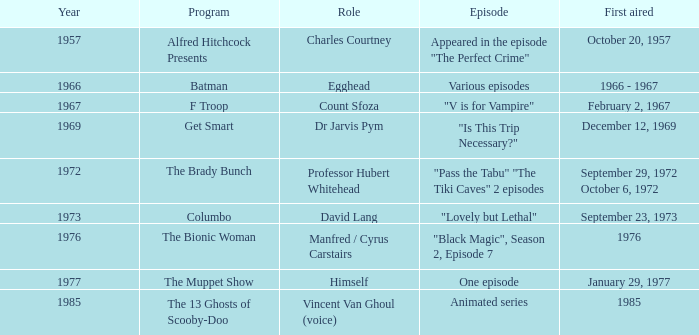What was the episode that had its debut in 1976? "Black Magic", Season 2, Episode 7. 